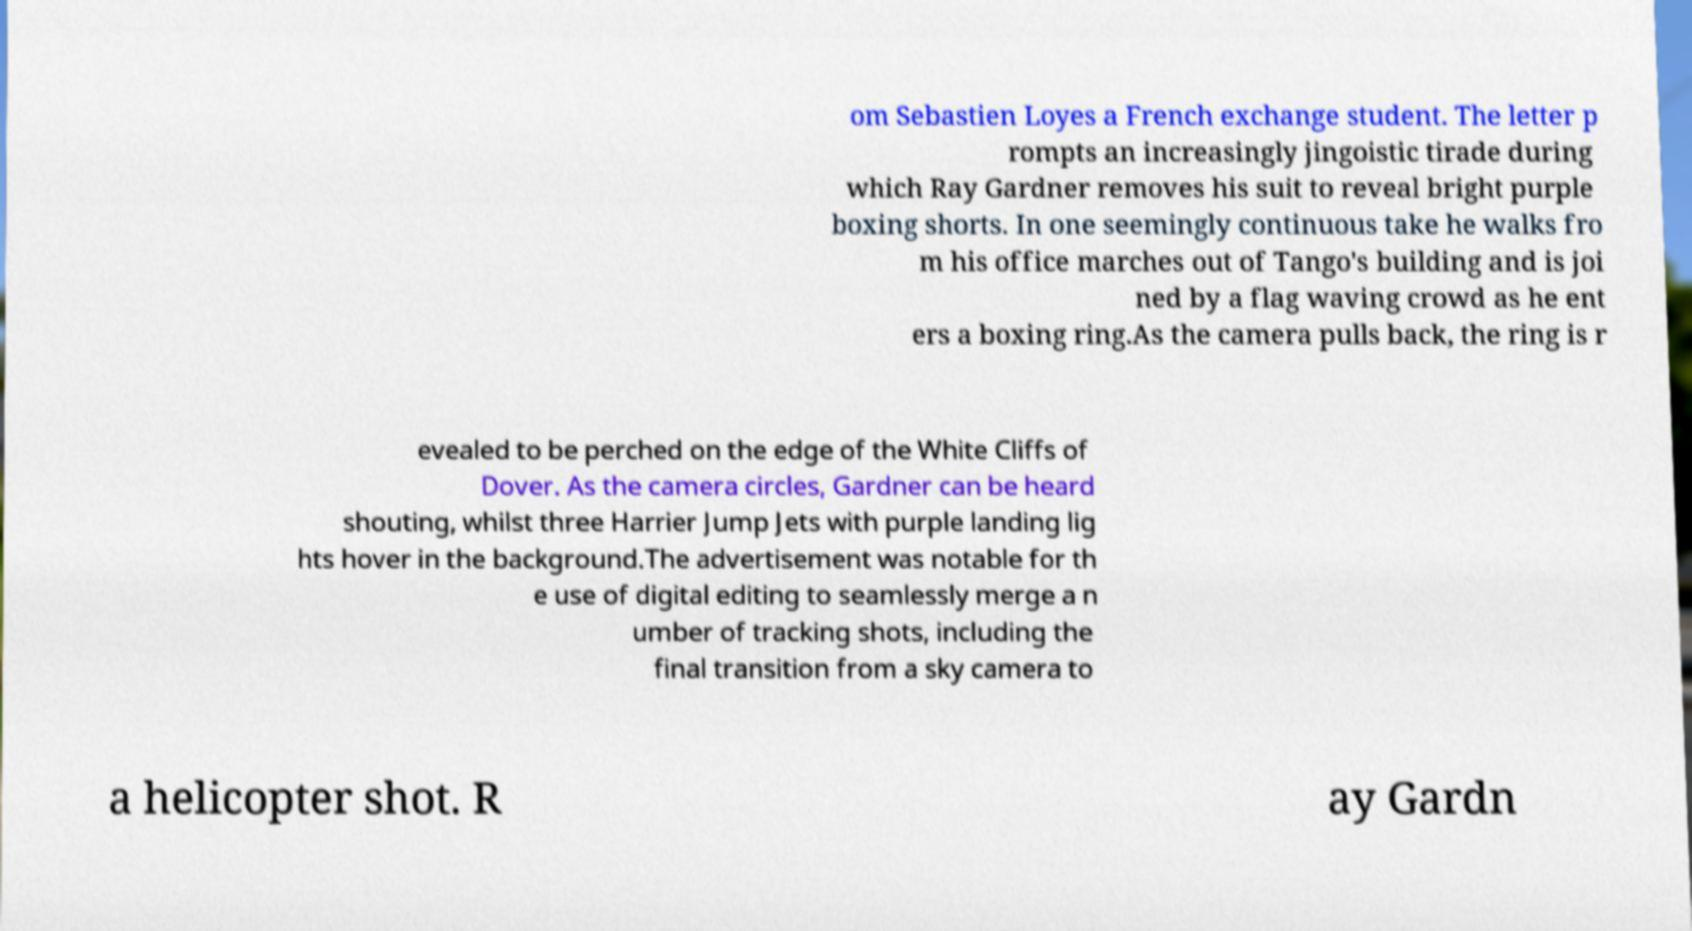I need the written content from this picture converted into text. Can you do that? om Sebastien Loyes a French exchange student. The letter p rompts an increasingly jingoistic tirade during which Ray Gardner removes his suit to reveal bright purple boxing shorts. In one seemingly continuous take he walks fro m his office marches out of Tango's building and is joi ned by a flag waving crowd as he ent ers a boxing ring.As the camera pulls back, the ring is r evealed to be perched on the edge of the White Cliffs of Dover. As the camera circles, Gardner can be heard shouting, whilst three Harrier Jump Jets with purple landing lig hts hover in the background.The advertisement was notable for th e use of digital editing to seamlessly merge a n umber of tracking shots, including the final transition from a sky camera to a helicopter shot. R ay Gardn 